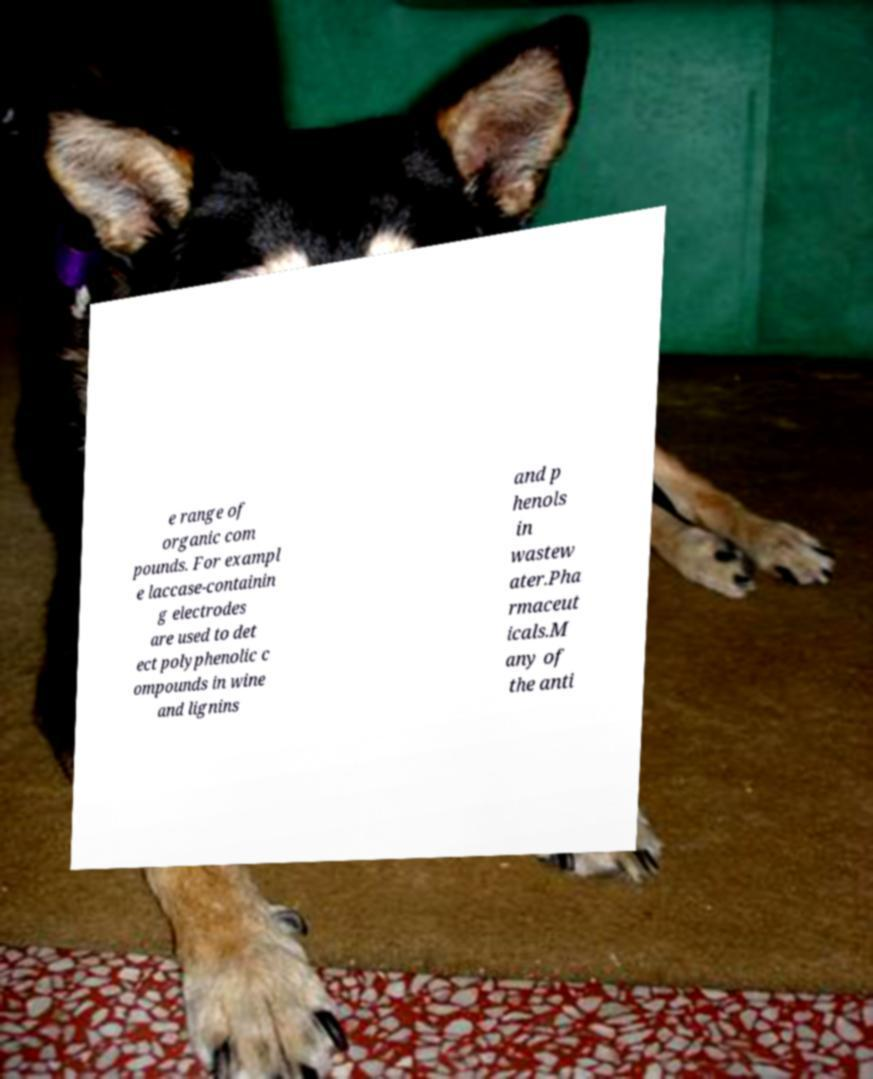Could you assist in decoding the text presented in this image and type it out clearly? e range of organic com pounds. For exampl e laccase-containin g electrodes are used to det ect polyphenolic c ompounds in wine and lignins and p henols in wastew ater.Pha rmaceut icals.M any of the anti 